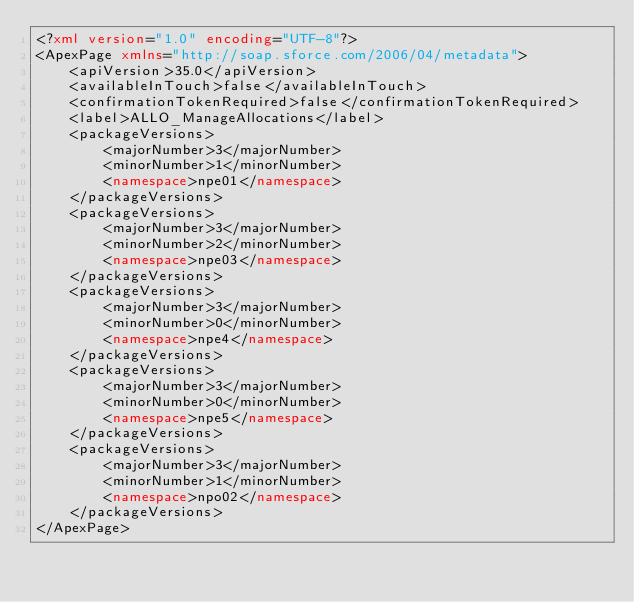<code> <loc_0><loc_0><loc_500><loc_500><_XML_><?xml version="1.0" encoding="UTF-8"?>
<ApexPage xmlns="http://soap.sforce.com/2006/04/metadata">
    <apiVersion>35.0</apiVersion>
    <availableInTouch>false</availableInTouch>
    <confirmationTokenRequired>false</confirmationTokenRequired>
    <label>ALLO_ManageAllocations</label>
    <packageVersions>
        <majorNumber>3</majorNumber>
        <minorNumber>1</minorNumber>
        <namespace>npe01</namespace>
    </packageVersions>
    <packageVersions>
        <majorNumber>3</majorNumber>
        <minorNumber>2</minorNumber>
        <namespace>npe03</namespace>
    </packageVersions>
    <packageVersions>
        <majorNumber>3</majorNumber>
        <minorNumber>0</minorNumber>
        <namespace>npe4</namespace>
    </packageVersions>
    <packageVersions>
        <majorNumber>3</majorNumber>
        <minorNumber>0</minorNumber>
        <namespace>npe5</namespace>
    </packageVersions>
    <packageVersions>
        <majorNumber>3</majorNumber>
        <minorNumber>1</minorNumber>
        <namespace>npo02</namespace>
    </packageVersions>
</ApexPage>
</code> 